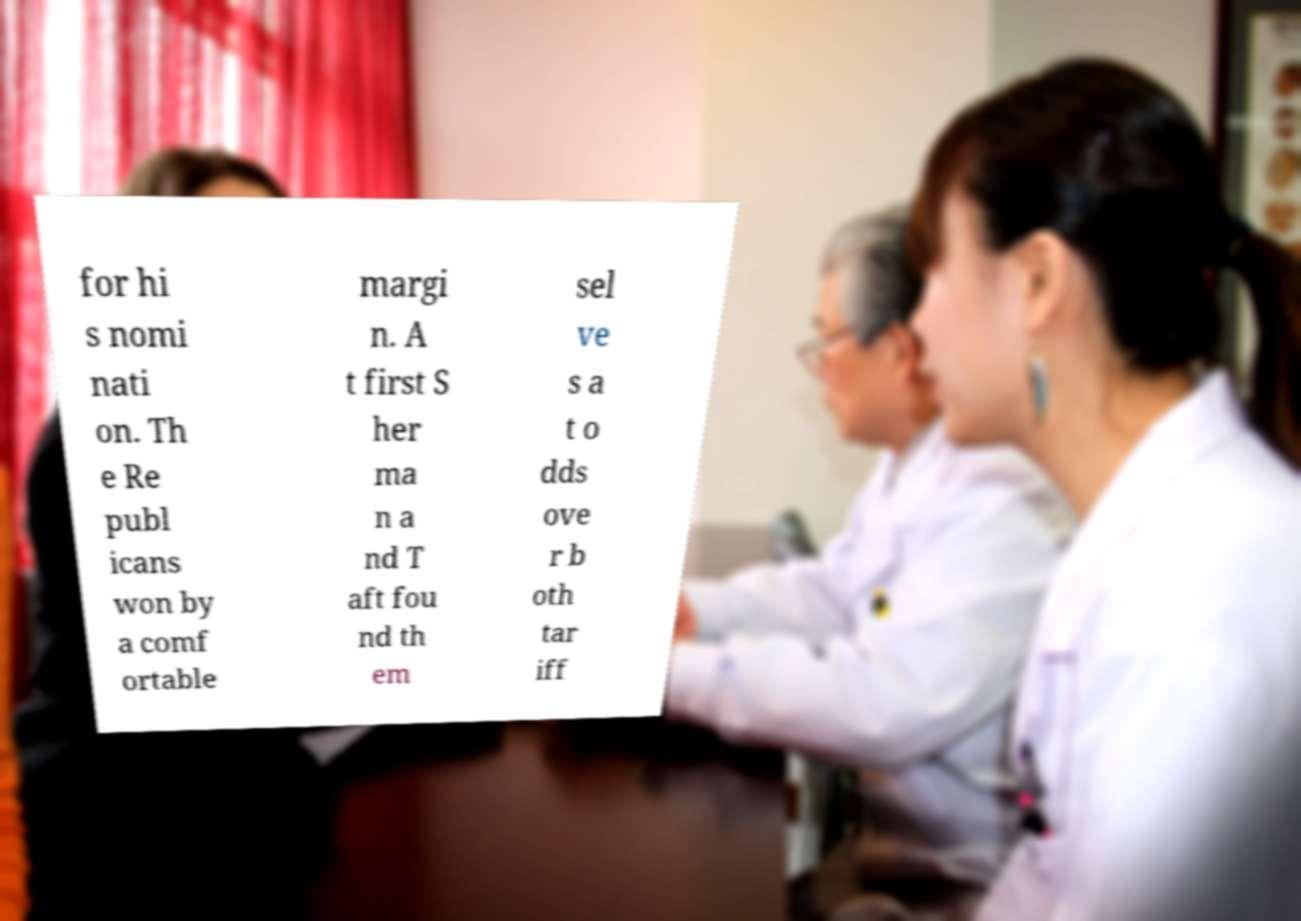Could you extract and type out the text from this image? for hi s nomi nati on. Th e Re publ icans won by a comf ortable margi n. A t first S her ma n a nd T aft fou nd th em sel ve s a t o dds ove r b oth tar iff 